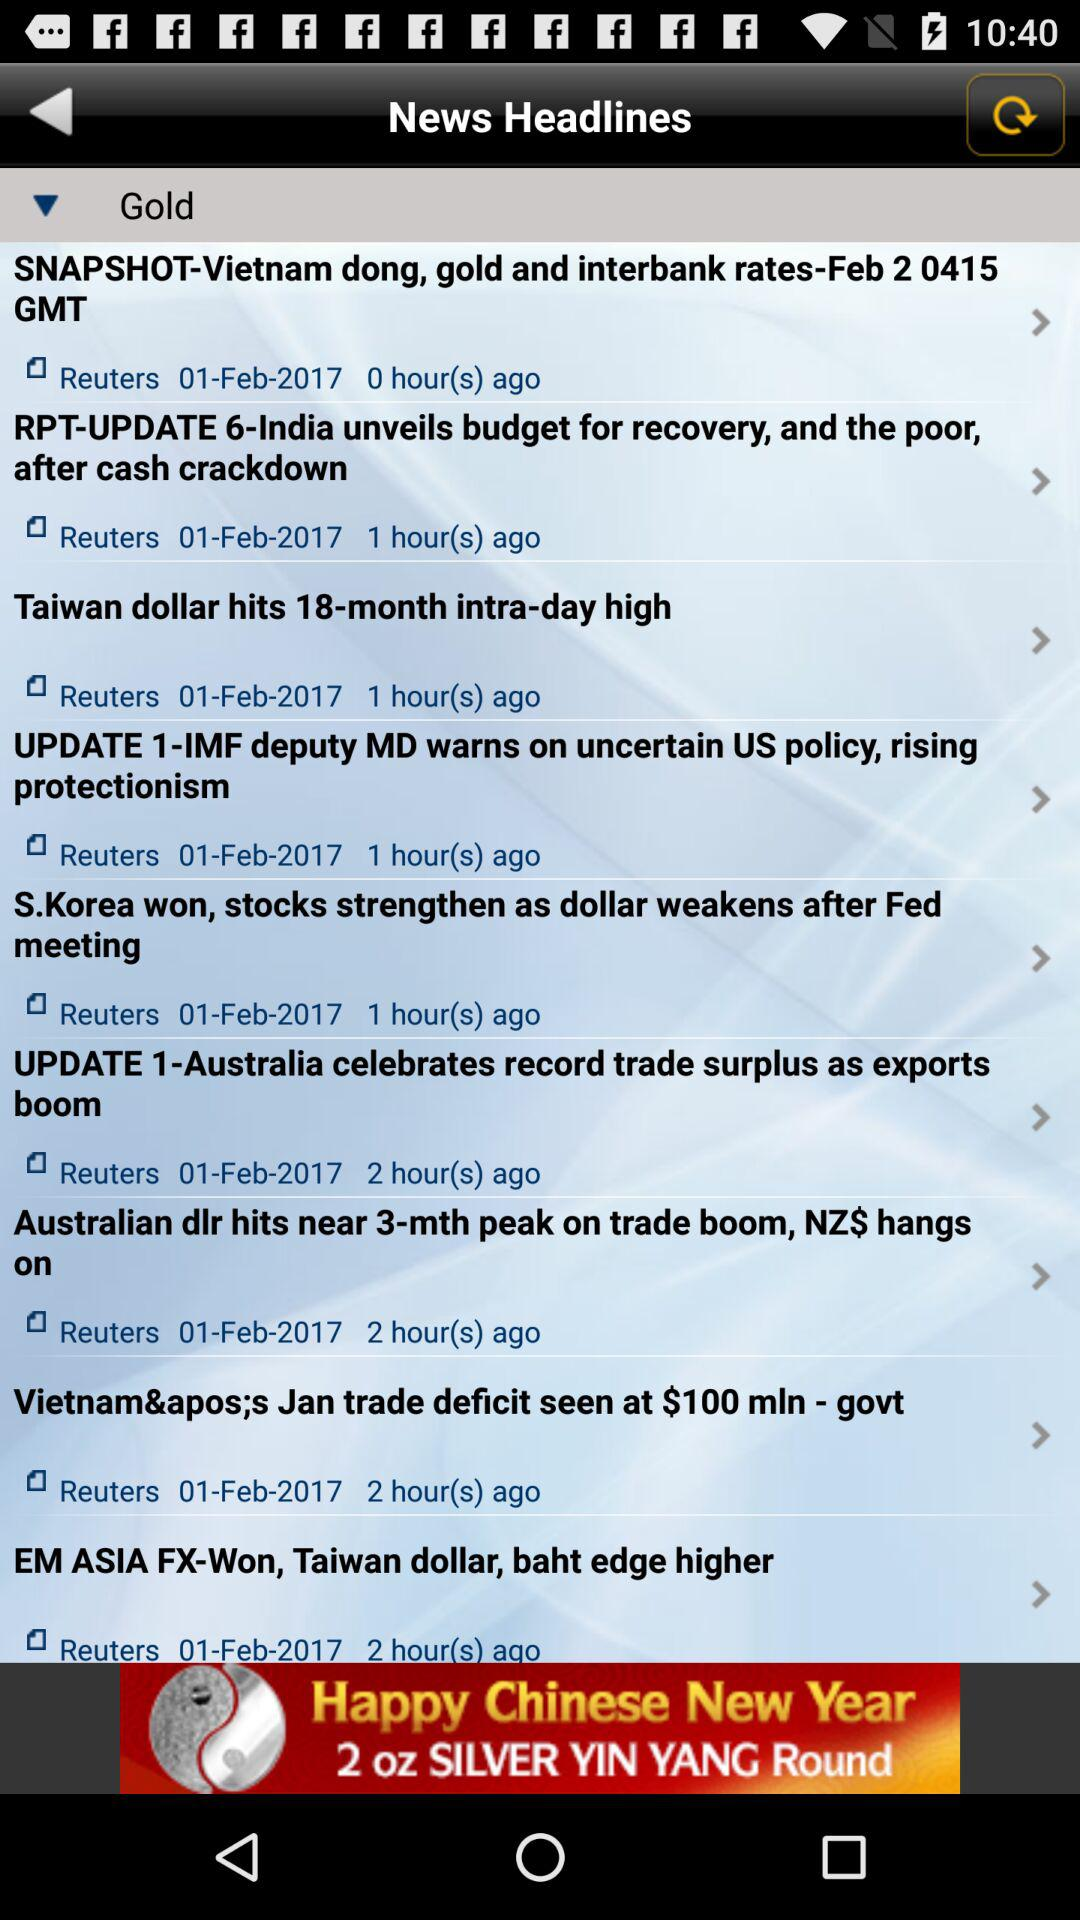What is the version number?
When the provided information is insufficient, respond with <no answer>. <no answer> 